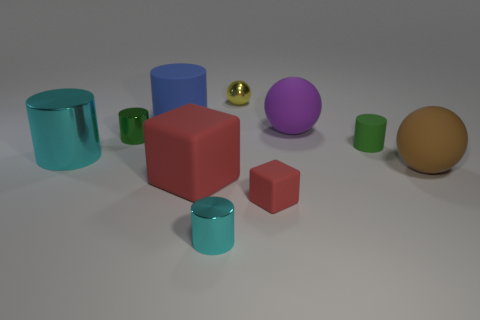How many metal objects are tiny cyan balls or tiny cubes?
Keep it short and to the point. 0. Is the large metallic object the same color as the small ball?
Your response must be concise. No. There is a large blue rubber thing; what number of cyan objects are in front of it?
Keep it short and to the point. 2. What number of red objects are to the left of the metallic ball and right of the shiny ball?
Offer a terse response. 0. The small green thing that is made of the same material as the brown ball is what shape?
Your answer should be very brief. Cylinder. Is the size of the cylinder that is to the right of the tiny yellow metal ball the same as the green thing that is on the left side of the big purple rubber object?
Ensure brevity in your answer.  Yes. The small thing to the left of the big blue matte cylinder is what color?
Your answer should be compact. Green. What is the material of the cyan object that is on the right side of the cyan thing that is to the left of the green shiny cylinder?
Offer a terse response. Metal. There is a brown matte object; what shape is it?
Your answer should be compact. Sphere. What material is the other tiny object that is the same shape as the brown object?
Keep it short and to the point. Metal. 